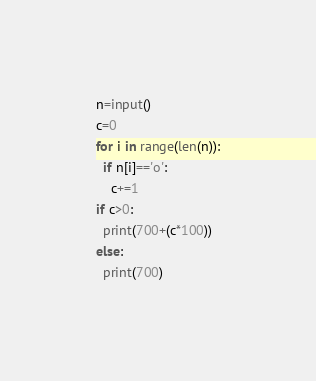<code> <loc_0><loc_0><loc_500><loc_500><_Python_>n=input()
c=0
for i in range(len(n)):
  if n[i]=='o':
    c+=1
if c>0:
  print(700+(c*100))
else:
  print(700)
</code> 